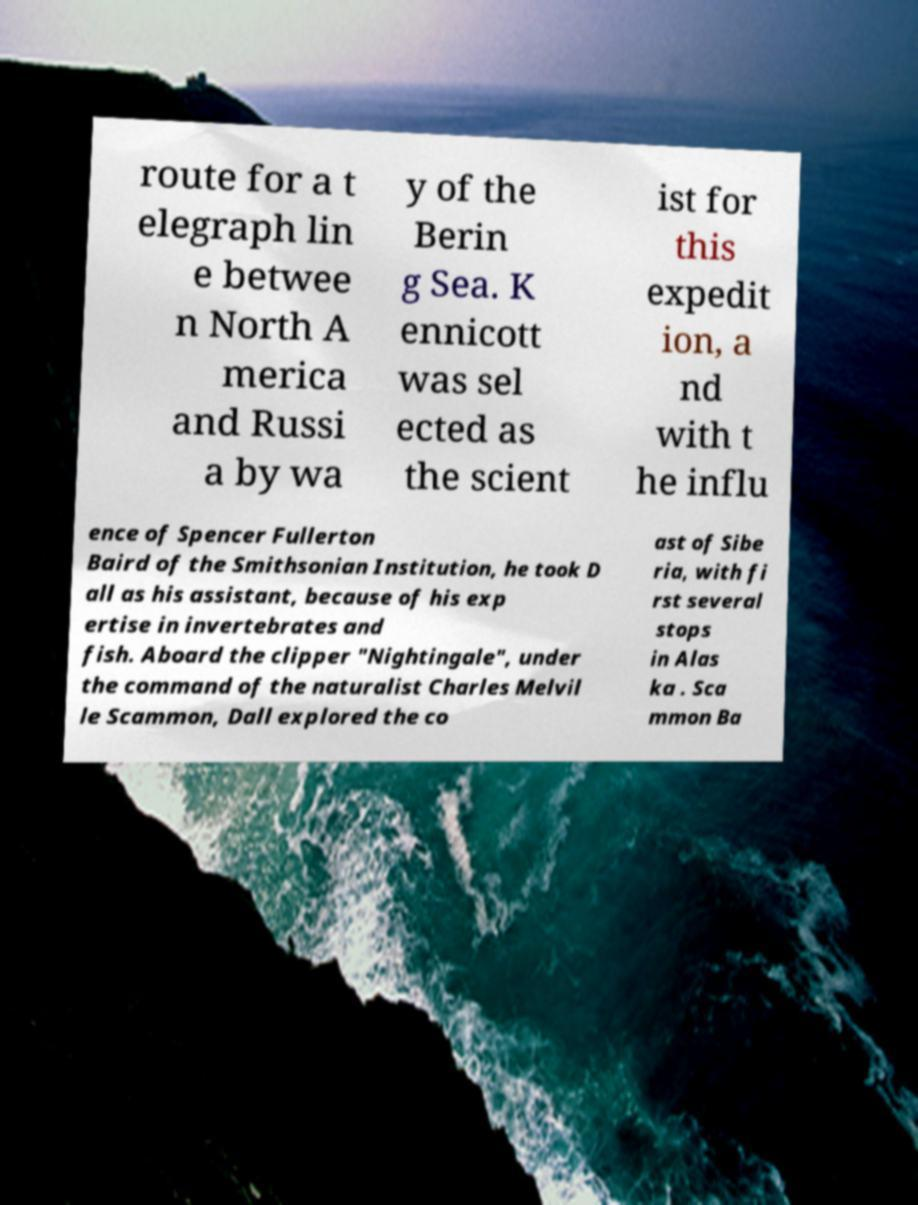Can you accurately transcribe the text from the provided image for me? route for a t elegraph lin e betwee n North A merica and Russi a by wa y of the Berin g Sea. K ennicott was sel ected as the scient ist for this expedit ion, a nd with t he influ ence of Spencer Fullerton Baird of the Smithsonian Institution, he took D all as his assistant, because of his exp ertise in invertebrates and fish. Aboard the clipper "Nightingale", under the command of the naturalist Charles Melvil le Scammon, Dall explored the co ast of Sibe ria, with fi rst several stops in Alas ka . Sca mmon Ba 